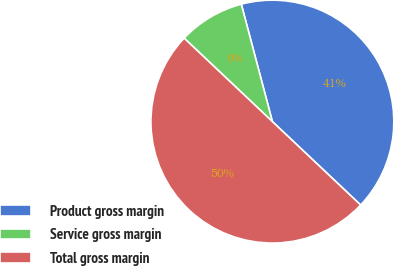Convert chart. <chart><loc_0><loc_0><loc_500><loc_500><pie_chart><fcel>Product gross margin<fcel>Service gross margin<fcel>Total gross margin<nl><fcel>41.17%<fcel>8.83%<fcel>50.0%<nl></chart> 